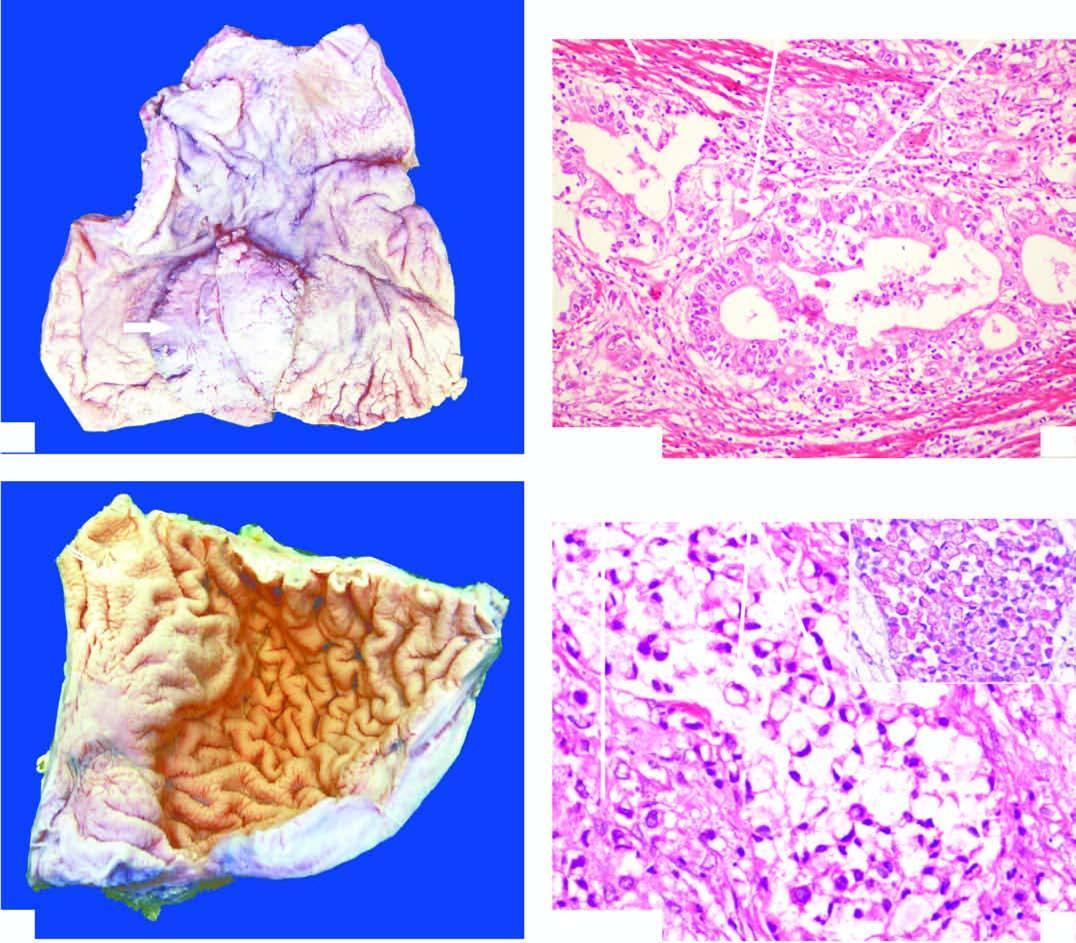re malignant cells forming irregular glands with stratification seen invading the layers of the stomach wall?
Answer the question using a single word or phrase. Yes 